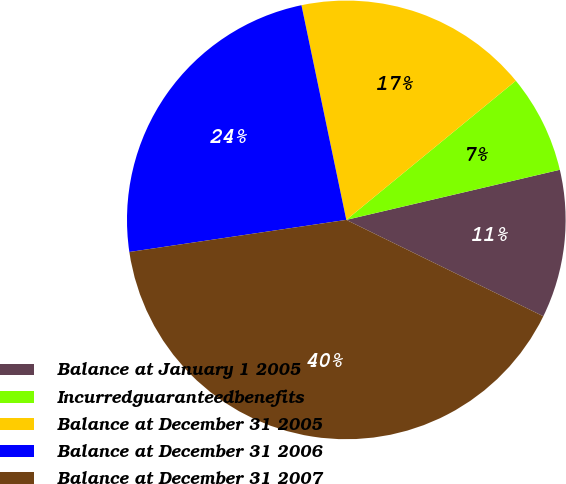Convert chart to OTSL. <chart><loc_0><loc_0><loc_500><loc_500><pie_chart><fcel>Balance at January 1 2005<fcel>Incurredguaranteedbenefits<fcel>Balance at December 31 2005<fcel>Balance at December 31 2006<fcel>Balance at December 31 2007<nl><fcel>10.91%<fcel>7.27%<fcel>17.34%<fcel>24.06%<fcel>40.42%<nl></chart> 